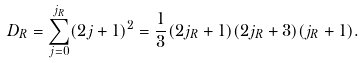<formula> <loc_0><loc_0><loc_500><loc_500>D _ { R } = \sum _ { j = 0 } ^ { j _ { R } } ( 2 j + 1 ) ^ { 2 } = \frac { 1 } { 3 } ( 2 j _ { R } + 1 ) ( 2 j _ { R } + 3 ) ( j _ { R } + 1 ) .</formula> 